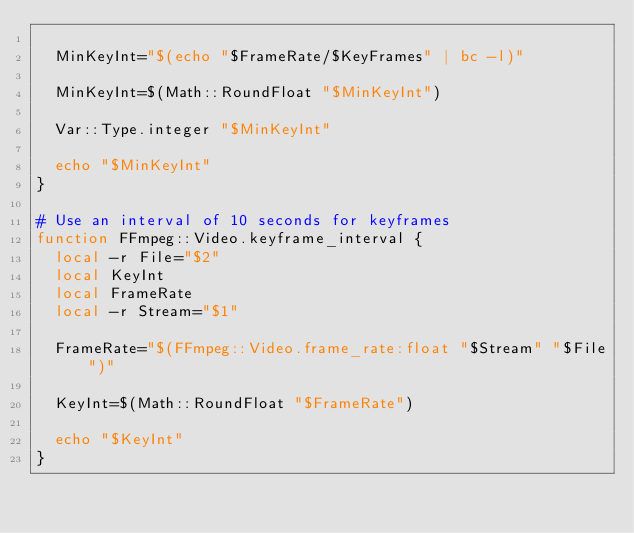<code> <loc_0><loc_0><loc_500><loc_500><_Bash_>
  MinKeyInt="$(echo "$FrameRate/$KeyFrames" | bc -l)"

  MinKeyInt=$(Math::RoundFloat "$MinKeyInt")

  Var::Type.integer "$MinKeyInt"

  echo "$MinKeyInt"
}

# Use an interval of 10 seconds for keyframes
function FFmpeg::Video.keyframe_interval {
  local -r File="$2"
  local KeyInt
  local FrameRate
  local -r Stream="$1"

  FrameRate="$(FFmpeg::Video.frame_rate:float "$Stream" "$File")"

  KeyInt=$(Math::RoundFloat "$FrameRate")

  echo "$KeyInt"
}
</code> 